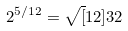Convert formula to latex. <formula><loc_0><loc_0><loc_500><loc_500>2 ^ { 5 / 1 2 } = \sqrt { [ } 1 2 ] { 3 2 }</formula> 